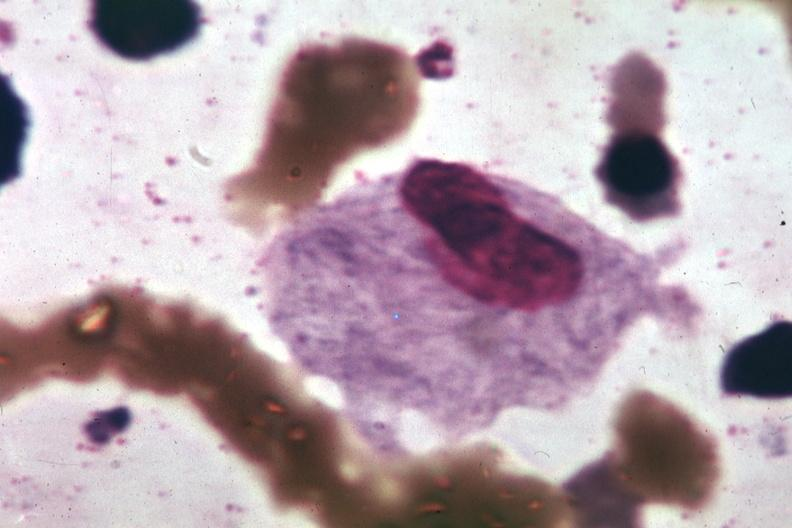what does this image show?
Answer the question using a single word or phrase. Wrights typical cell 